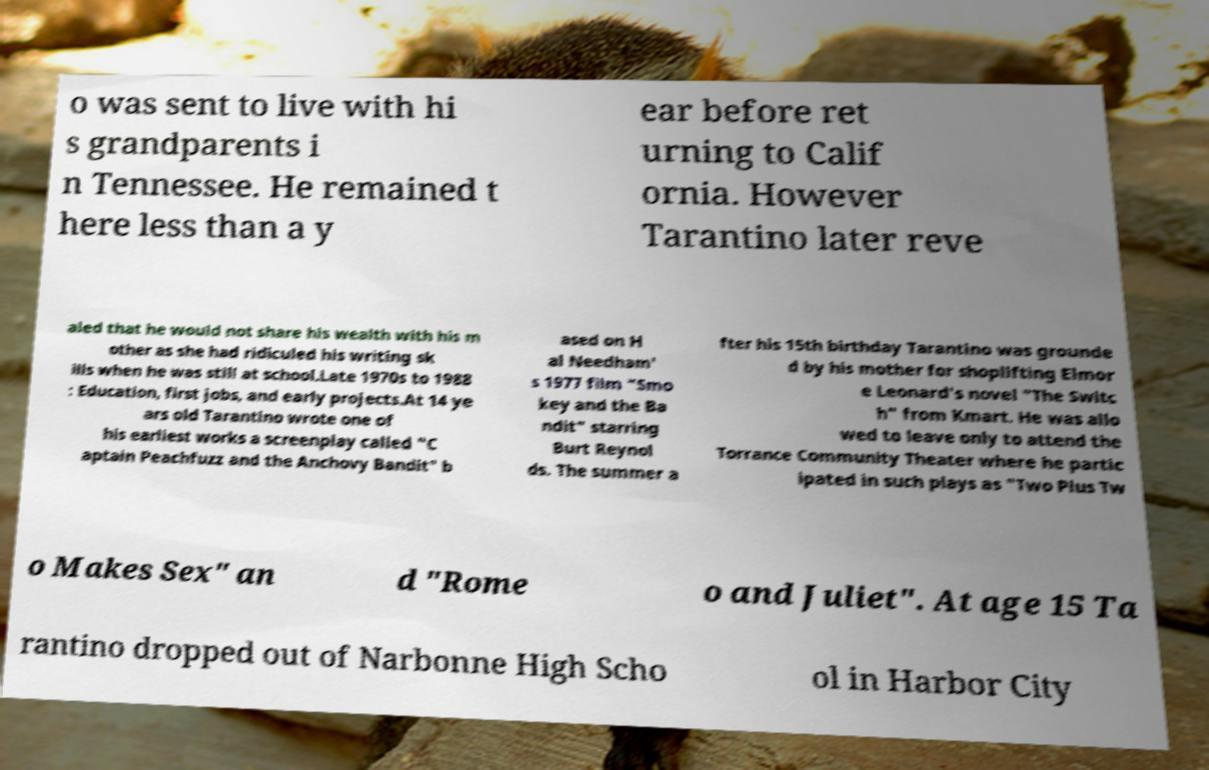Could you extract and type out the text from this image? o was sent to live with hi s grandparents i n Tennessee. He remained t here less than a y ear before ret urning to Calif ornia. However Tarantino later reve aled that he would not share his wealth with his m other as she had ridiculed his writing sk ills when he was still at school.Late 1970s to 1988 : Education, first jobs, and early projects.At 14 ye ars old Tarantino wrote one of his earliest works a screenplay called "C aptain Peachfuzz and the Anchovy Bandit" b ased on H al Needham' s 1977 film "Smo key and the Ba ndit" starring Burt Reynol ds. The summer a fter his 15th birthday Tarantino was grounde d by his mother for shoplifting Elmor e Leonard's novel "The Switc h" from Kmart. He was allo wed to leave only to attend the Torrance Community Theater where he partic ipated in such plays as "Two Plus Tw o Makes Sex" an d "Rome o and Juliet". At age 15 Ta rantino dropped out of Narbonne High Scho ol in Harbor City 